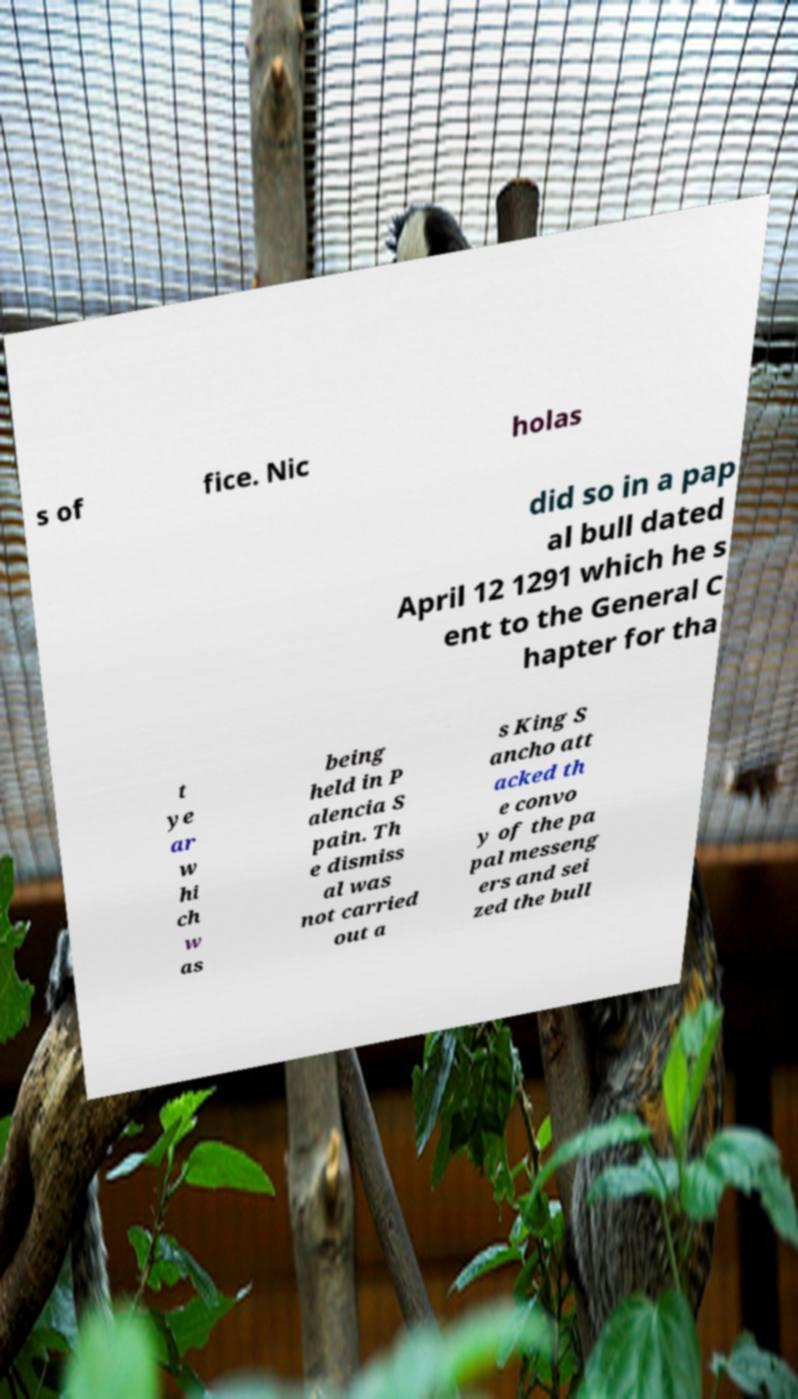What messages or text are displayed in this image? I need them in a readable, typed format. s of fice. Nic holas did so in a pap al bull dated April 12 1291 which he s ent to the General C hapter for tha t ye ar w hi ch w as being held in P alencia S pain. Th e dismiss al was not carried out a s King S ancho att acked th e convo y of the pa pal messeng ers and sei zed the bull 